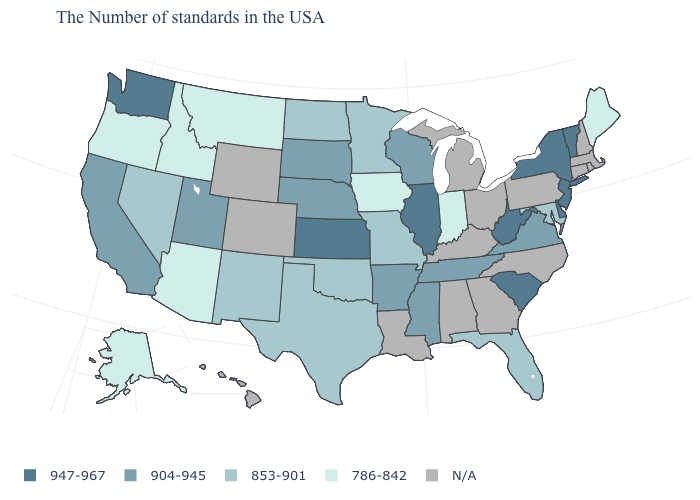Does Vermont have the highest value in the Northeast?
Give a very brief answer. Yes. Among the states that border Idaho , which have the lowest value?
Write a very short answer. Montana, Oregon. What is the value of North Carolina?
Give a very brief answer. N/A. Which states hav the highest value in the MidWest?
Give a very brief answer. Illinois, Kansas. What is the value of New Hampshire?
Quick response, please. N/A. Does Minnesota have the lowest value in the USA?
Answer briefly. No. Does the first symbol in the legend represent the smallest category?
Answer briefly. No. What is the value of Iowa?
Short answer required. 786-842. What is the value of Idaho?
Answer briefly. 786-842. Name the states that have a value in the range 947-967?
Concise answer only. Vermont, New York, New Jersey, Delaware, South Carolina, West Virginia, Illinois, Kansas, Washington. What is the value of Kansas?
Answer briefly. 947-967. What is the value of South Carolina?
Concise answer only. 947-967. What is the value of Maine?
Quick response, please. 786-842. What is the value of Mississippi?
Write a very short answer. 904-945. 